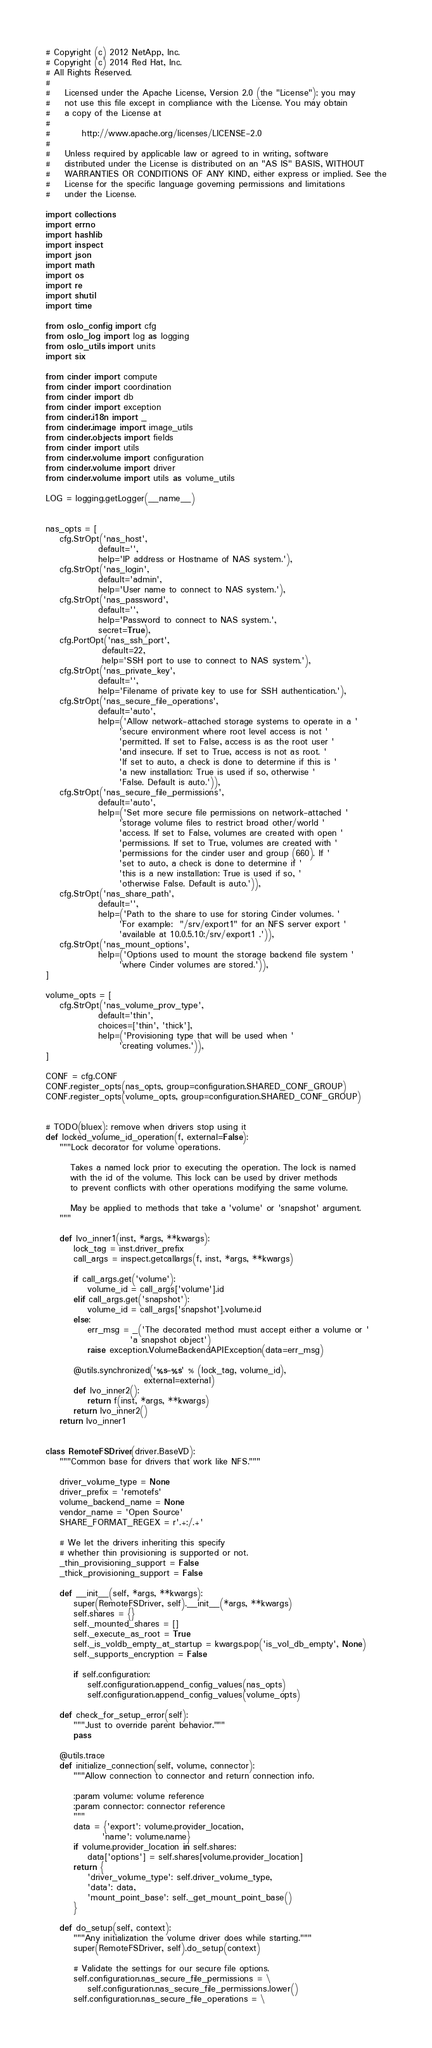<code> <loc_0><loc_0><loc_500><loc_500><_Python_># Copyright (c) 2012 NetApp, Inc.
# Copyright (c) 2014 Red Hat, Inc.
# All Rights Reserved.
#
#    Licensed under the Apache License, Version 2.0 (the "License"); you may
#    not use this file except in compliance with the License. You may obtain
#    a copy of the License at
#
#         http://www.apache.org/licenses/LICENSE-2.0
#
#    Unless required by applicable law or agreed to in writing, software
#    distributed under the License is distributed on an "AS IS" BASIS, WITHOUT
#    WARRANTIES OR CONDITIONS OF ANY KIND, either express or implied. See the
#    License for the specific language governing permissions and limitations
#    under the License.

import collections
import errno
import hashlib
import inspect
import json
import math
import os
import re
import shutil
import time

from oslo_config import cfg
from oslo_log import log as logging
from oslo_utils import units
import six

from cinder import compute
from cinder import coordination
from cinder import db
from cinder import exception
from cinder.i18n import _
from cinder.image import image_utils
from cinder.objects import fields
from cinder import utils
from cinder.volume import configuration
from cinder.volume import driver
from cinder.volume import utils as volume_utils

LOG = logging.getLogger(__name__)


nas_opts = [
    cfg.StrOpt('nas_host',
               default='',
               help='IP address or Hostname of NAS system.'),
    cfg.StrOpt('nas_login',
               default='admin',
               help='User name to connect to NAS system.'),
    cfg.StrOpt('nas_password',
               default='',
               help='Password to connect to NAS system.',
               secret=True),
    cfg.PortOpt('nas_ssh_port',
                default=22,
                help='SSH port to use to connect to NAS system.'),
    cfg.StrOpt('nas_private_key',
               default='',
               help='Filename of private key to use for SSH authentication.'),
    cfg.StrOpt('nas_secure_file_operations',
               default='auto',
               help=('Allow network-attached storage systems to operate in a '
                     'secure environment where root level access is not '
                     'permitted. If set to False, access is as the root user '
                     'and insecure. If set to True, access is not as root. '
                     'If set to auto, a check is done to determine if this is '
                     'a new installation: True is used if so, otherwise '
                     'False. Default is auto.')),
    cfg.StrOpt('nas_secure_file_permissions',
               default='auto',
               help=('Set more secure file permissions on network-attached '
                     'storage volume files to restrict broad other/world '
                     'access. If set to False, volumes are created with open '
                     'permissions. If set to True, volumes are created with '
                     'permissions for the cinder user and group (660). If '
                     'set to auto, a check is done to determine if '
                     'this is a new installation: True is used if so, '
                     'otherwise False. Default is auto.')),
    cfg.StrOpt('nas_share_path',
               default='',
               help=('Path to the share to use for storing Cinder volumes. '
                     'For example:  "/srv/export1" for an NFS server export '
                     'available at 10.0.5.10:/srv/export1 .')),
    cfg.StrOpt('nas_mount_options',
               help=('Options used to mount the storage backend file system '
                     'where Cinder volumes are stored.')),
]

volume_opts = [
    cfg.StrOpt('nas_volume_prov_type',
               default='thin',
               choices=['thin', 'thick'],
               help=('Provisioning type that will be used when '
                     'creating volumes.')),
]

CONF = cfg.CONF
CONF.register_opts(nas_opts, group=configuration.SHARED_CONF_GROUP)
CONF.register_opts(volume_opts, group=configuration.SHARED_CONF_GROUP)


# TODO(bluex): remove when drivers stop using it
def locked_volume_id_operation(f, external=False):
    """Lock decorator for volume operations.

       Takes a named lock prior to executing the operation. The lock is named
       with the id of the volume. This lock can be used by driver methods
       to prevent conflicts with other operations modifying the same volume.

       May be applied to methods that take a 'volume' or 'snapshot' argument.
    """

    def lvo_inner1(inst, *args, **kwargs):
        lock_tag = inst.driver_prefix
        call_args = inspect.getcallargs(f, inst, *args, **kwargs)

        if call_args.get('volume'):
            volume_id = call_args['volume'].id
        elif call_args.get('snapshot'):
            volume_id = call_args['snapshot'].volume.id
        else:
            err_msg = _('The decorated method must accept either a volume or '
                        'a snapshot object')
            raise exception.VolumeBackendAPIException(data=err_msg)

        @utils.synchronized('%s-%s' % (lock_tag, volume_id),
                            external=external)
        def lvo_inner2():
            return f(inst, *args, **kwargs)
        return lvo_inner2()
    return lvo_inner1


class RemoteFSDriver(driver.BaseVD):
    """Common base for drivers that work like NFS."""

    driver_volume_type = None
    driver_prefix = 'remotefs'
    volume_backend_name = None
    vendor_name = 'Open Source'
    SHARE_FORMAT_REGEX = r'.+:/.+'

    # We let the drivers inheriting this specify
    # whether thin provisioning is supported or not.
    _thin_provisioning_support = False
    _thick_provisioning_support = False

    def __init__(self, *args, **kwargs):
        super(RemoteFSDriver, self).__init__(*args, **kwargs)
        self.shares = {}
        self._mounted_shares = []
        self._execute_as_root = True
        self._is_voldb_empty_at_startup = kwargs.pop('is_vol_db_empty', None)
        self._supports_encryption = False

        if self.configuration:
            self.configuration.append_config_values(nas_opts)
            self.configuration.append_config_values(volume_opts)

    def check_for_setup_error(self):
        """Just to override parent behavior."""
        pass

    @utils.trace
    def initialize_connection(self, volume, connector):
        """Allow connection to connector and return connection info.

        :param volume: volume reference
        :param connector: connector reference
        """
        data = {'export': volume.provider_location,
                'name': volume.name}
        if volume.provider_location in self.shares:
            data['options'] = self.shares[volume.provider_location]
        return {
            'driver_volume_type': self.driver_volume_type,
            'data': data,
            'mount_point_base': self._get_mount_point_base()
        }

    def do_setup(self, context):
        """Any initialization the volume driver does while starting."""
        super(RemoteFSDriver, self).do_setup(context)

        # Validate the settings for our secure file options.
        self.configuration.nas_secure_file_permissions = \
            self.configuration.nas_secure_file_permissions.lower()
        self.configuration.nas_secure_file_operations = \</code> 